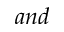<formula> <loc_0><loc_0><loc_500><loc_500>a n d</formula> 